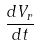<formula> <loc_0><loc_0><loc_500><loc_500>\frac { d V _ { r } } { d t }</formula> 